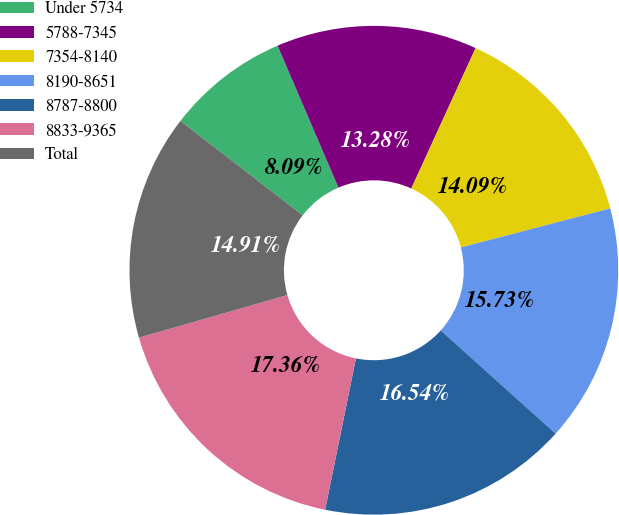Convert chart to OTSL. <chart><loc_0><loc_0><loc_500><loc_500><pie_chart><fcel>Under 5734<fcel>5788-7345<fcel>7354-8140<fcel>8190-8651<fcel>8787-8800<fcel>8833-9365<fcel>Total<nl><fcel>8.09%<fcel>13.28%<fcel>14.09%<fcel>15.73%<fcel>16.54%<fcel>17.36%<fcel>14.91%<nl></chart> 